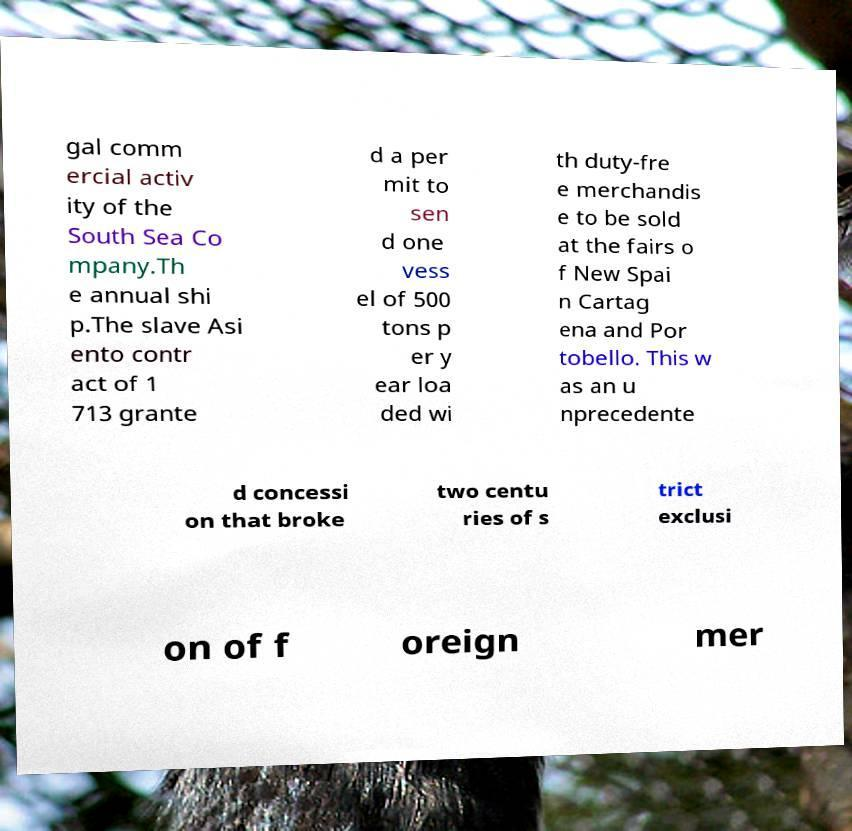Could you extract and type out the text from this image? gal comm ercial activ ity of the South Sea Co mpany.Th e annual shi p.The slave Asi ento contr act of 1 713 grante d a per mit to sen d one vess el of 500 tons p er y ear loa ded wi th duty-fre e merchandis e to be sold at the fairs o f New Spai n Cartag ena and Por tobello. This w as an u nprecedente d concessi on that broke two centu ries of s trict exclusi on of f oreign mer 